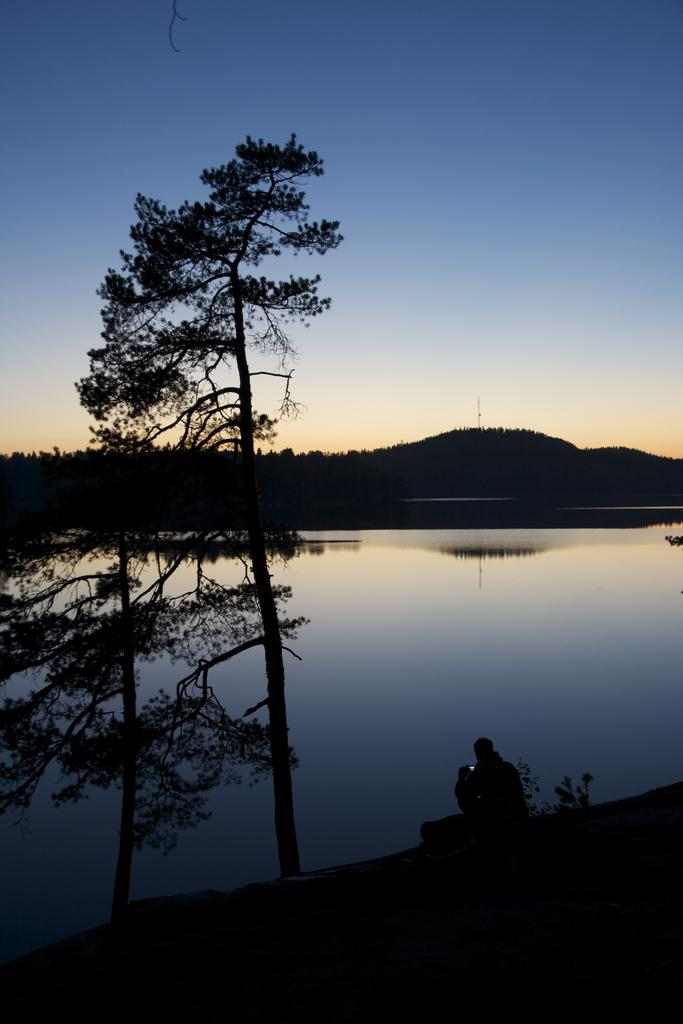What is the person in the image doing? There is a person sitting in the image. What can be seen in the background of the image? There is water and trees visible in the background of the image. What is the color of the sky in the image? The sky is blue and white in color. What type of rhythm can be heard coming from the bottle in the image? There is no bottle present in the image, and therefore no rhythm can be heard. Can you see any worms crawling on the person in the image? There are no worms visible in the image; the person is sitting and there are no crawling creatures present. 